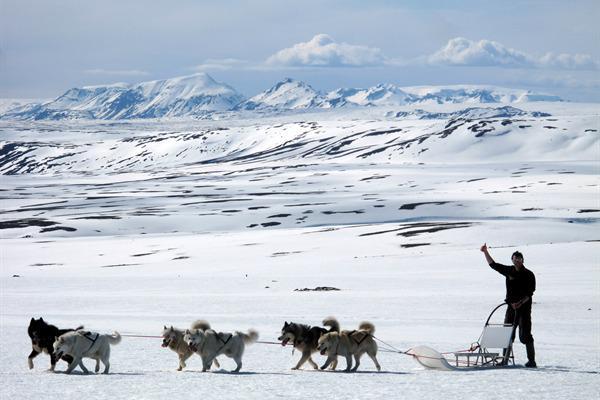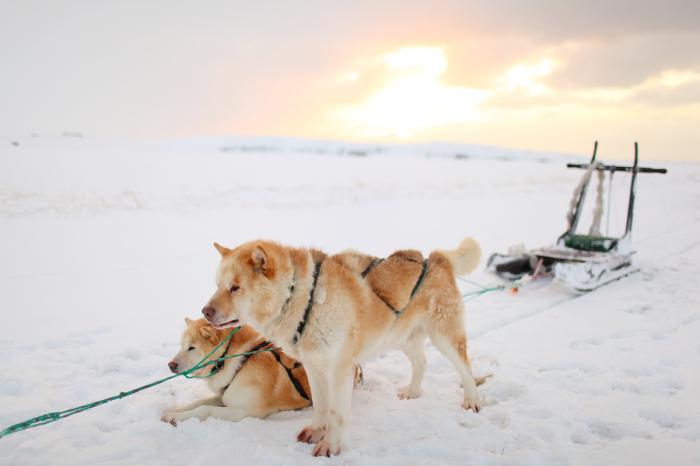The first image is the image on the left, the second image is the image on the right. Evaluate the accuracy of this statement regarding the images: "At least one of the sleds is empty.". Is it true? Answer yes or no. Yes. The first image is the image on the left, the second image is the image on the right. Given the left and right images, does the statement "In one image, mountains form the backdrop to the sled dog team." hold true? Answer yes or no. Yes. 